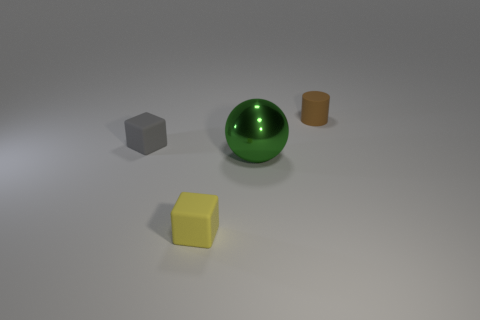If these objects were part of a children's toy set, what could you say about the set? If these objects were part of a children's toy set, it could suggest an educational purpose, perhaps designed to teach children about shapes, colors, and materials. The distinct shapes—the sphere, cylinder, and cubes—along with the variety of colors could aid in developing recognition skills and categorization. Moreover, the difference in textures might be intended to stimulate sensory exploration and develop tactile discernment. 